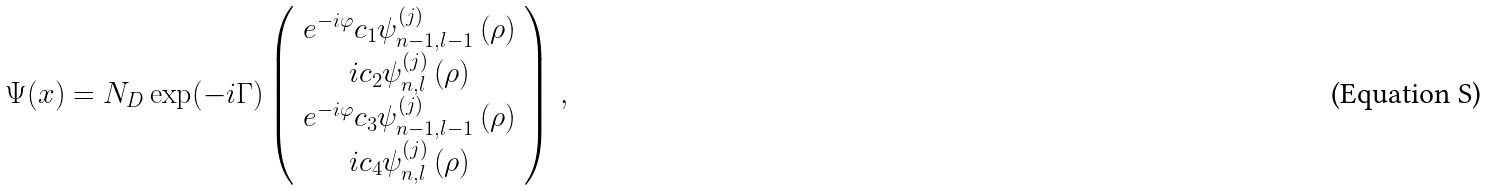<formula> <loc_0><loc_0><loc_500><loc_500>\Psi ( x ) = N _ { D } \exp ( - i \Gamma ) \left ( \begin{array} { c } e ^ { - i \varphi } c _ { 1 } \psi _ { n - 1 , l - 1 } ^ { ( j ) } \left ( \rho \right ) \\ i c _ { 2 } \psi _ { n , l } ^ { ( j ) } \left ( \rho \right ) \\ e ^ { - i \varphi } c _ { 3 } \psi _ { n - 1 , l - 1 } ^ { ( j ) } \left ( \rho \right ) \\ i c _ { 4 } \psi _ { n , l } ^ { ( j ) } \left ( \rho \right ) \end{array} \right ) \, ,</formula> 